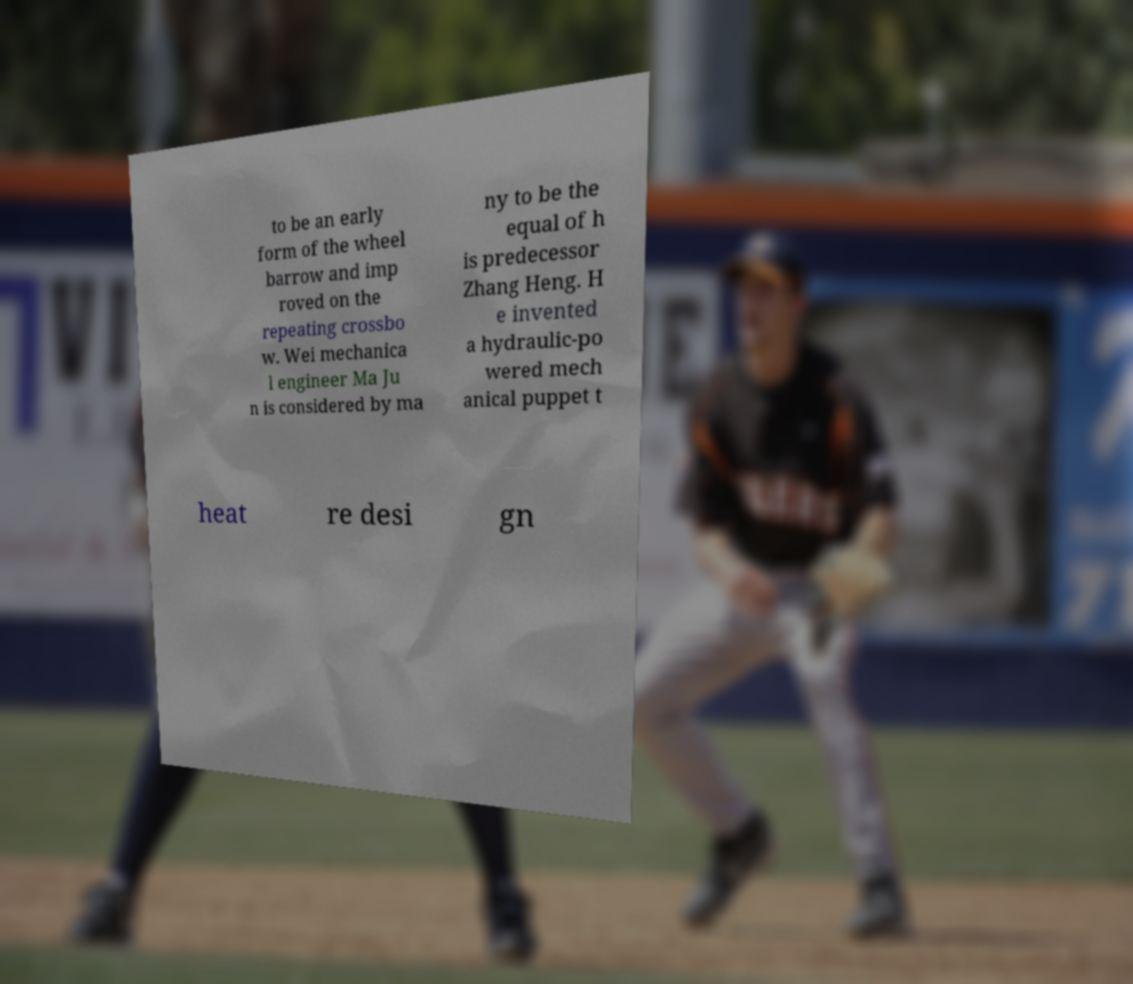Please identify and transcribe the text found in this image. to be an early form of the wheel barrow and imp roved on the repeating crossbo w. Wei mechanica l engineer Ma Ju n is considered by ma ny to be the equal of h is predecessor Zhang Heng. H e invented a hydraulic-po wered mech anical puppet t heat re desi gn 